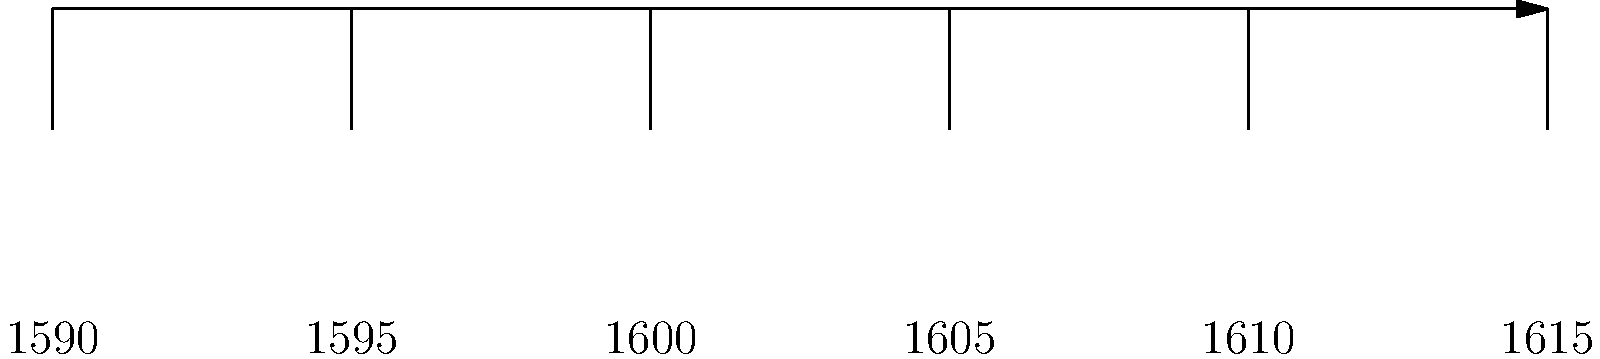Based on the timeline of Shakespeare's plays shown above, which play was written closest to the midpoint between "Romeo and Juliet" and "The Tempest"? To find the play written closest to the midpoint between "Romeo and Juliet" and "The Tempest", we need to follow these steps:

1. Identify the years for "Romeo and Juliet" and "The Tempest":
   - Romeo and Juliet: 1595
   - The Tempest: 1611

2. Calculate the midpoint year:
   $\text{Midpoint} = \frac{1595 + 1611}{2} = 1603$

3. Compare the years of the other plays to this midpoint:
   - Henry VI, Part 2: 1591
   - Hamlet: 1601
   - King Lear: 1606

4. Calculate the difference between each play's year and the midpoint:
   - Henry VI, Part 2: |1591 - 1603| = 12 years
   - Hamlet: |1601 - 1603| = 2 years
   - King Lear: |1606 - 1603| = 3 years

5. The play with the smallest difference from the midpoint is the answer.

Hamlet has the smallest difference of 2 years from the midpoint, making it the closest to the midpoint between "Romeo and Juliet" and "The Tempest".
Answer: Hamlet 